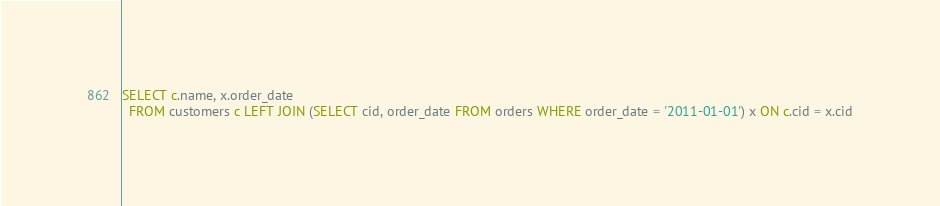Convert code to text. <code><loc_0><loc_0><loc_500><loc_500><_SQL_>SELECT c.name, x.order_date 
  FROM customers c LEFT JOIN (SELECT cid, order_date FROM orders WHERE order_date = '2011-01-01') x ON c.cid = x.cid
</code> 